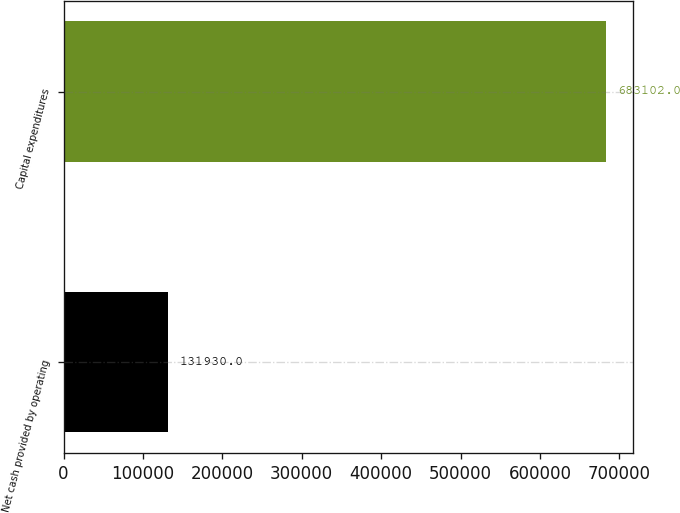Convert chart. <chart><loc_0><loc_0><loc_500><loc_500><bar_chart><fcel>Net cash provided by operating<fcel>Capital expenditures<nl><fcel>131930<fcel>683102<nl></chart> 